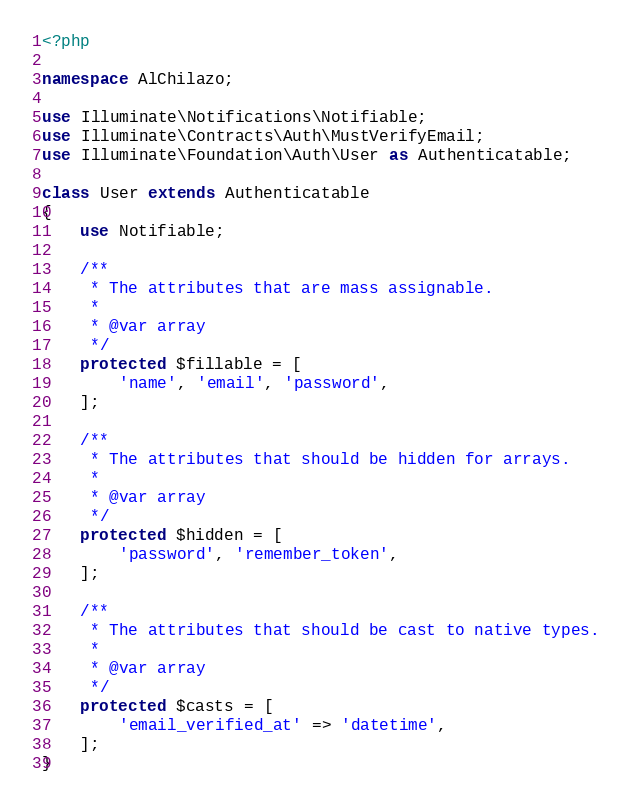<code> <loc_0><loc_0><loc_500><loc_500><_PHP_><?php

namespace AlChilazo;

use Illuminate\Notifications\Notifiable;
use Illuminate\Contracts\Auth\MustVerifyEmail;
use Illuminate\Foundation\Auth\User as Authenticatable;

class User extends Authenticatable
{
    use Notifiable;

    /**
     * The attributes that are mass assignable.
     *
     * @var array
     */
    protected $fillable = [
        'name', 'email', 'password',
    ];

    /**
     * The attributes that should be hidden for arrays.
     *
     * @var array
     */
    protected $hidden = [
        'password', 'remember_token',
    ];

    /**
     * The attributes that should be cast to native types.
     *
     * @var array
     */
    protected $casts = [
        'email_verified_at' => 'datetime',
    ];
}
</code> 